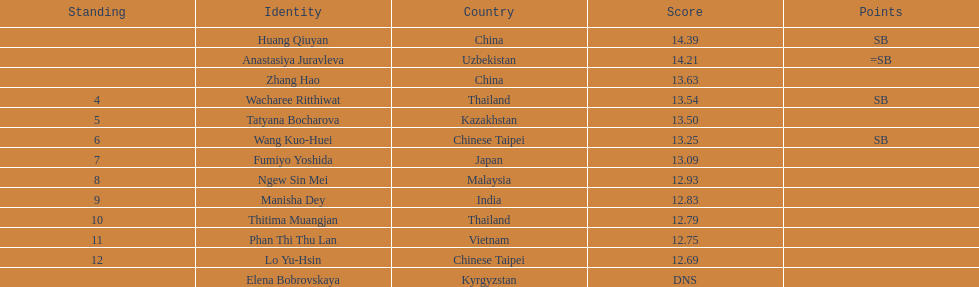What was the average result of the top three jumpers? 14.08. 